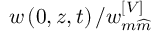Convert formula to latex. <formula><loc_0><loc_0><loc_500><loc_500>w \left ( 0 , z , t \right ) / w _ { m \widehat { m } } ^ { \left [ V \right ] }</formula> 